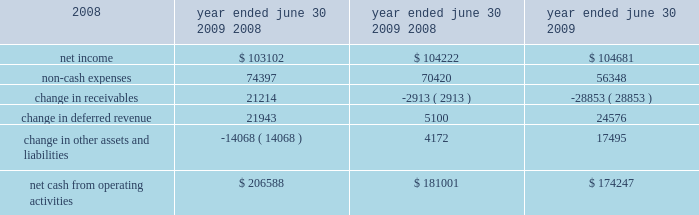26 | 2009 annual report in fiscal 2008 , revenues in the credit union systems and services business segment increased 14% ( 14 % ) from fiscal 2007 .
All revenue components within the segment experienced growth during fiscal 2008 .
License revenue generated the largest dollar growth in revenue as episys ae , our flagship core processing system aimed at larger credit unions , experienced strong sales throughout the year .
Support and service revenue , which is the largest component of total revenues for the credit union segment , experienced 34 percent growth in eft support and 10 percent growth in in-house support .
Gross profit in this business segment increased $ 9344 in fiscal 2008 compared to fiscal 2007 , due primarily to the increase in license revenue , which carries the highest margins .
Liquidity and capital resources we have historically generated positive cash flow from operations and have generally used funds generated from operations and short-term borrowings on our revolving credit facility to meet capital requirements .
We expect this trend to continue in the future .
The company 2019s cash and cash equivalents increased to $ 118251 at june 30 , 2009 from $ 65565 at june 30 , 2008 .
The table summarizes net cash from operating activities in the statement of cash flows : 2009 2008 2007 .
Year ended june 30 , cash provided by operations increased $ 25587 to $ 206588 for the fiscal year ended june 30 , 2009 as compared to $ 181001 for the fiscal year ended june 30 , 2008 .
This increase is primarily attributable to a decrease in receivables compared to the same period a year ago of $ 21214 .
This decrease is largely the result of fiscal 2010 annual software maintenance billings being provided to customers earlier than in the prior year , which allowed more cash to be collected before the end of the fiscal year than in previous years .
Further , we collected more cash overall related to revenues that will be recognized in subsequent periods in the current year than in fiscal 2008 .
Cash used in investing activities for the fiscal year ended june 2009 was $ 59227 and includes $ 3027 in contingent consideration paid on prior years 2019 acquisitions .
Cash used in investing activities for the fiscal year ended june 2008 was $ 102148 and includes payments for acquisitions of $ 48109 , plus $ 1215 in contingent consideration paid on prior years 2019 acquisitions .
Capital expenditures for fiscal 2009 were $ 31562 compared to $ 31105 for fiscal 2008 .
Cash used for software development in fiscal 2009 was $ 24684 compared to $ 23736 during the prior year .
Net cash used in financing activities for the current fiscal year was $ 94675 and includes the repurchase of 3106 shares of our common stock for $ 58405 , the payment of dividends of $ 26903 and $ 13489 net repayment on our revolving credit facilities .
Cash used in financing activities was partially offset by proceeds of $ 3773 from the exercise of stock options and the sale of common stock ( through the employee stock purchase plan ) and $ 348 excess tax benefits from stock option exercises .
During fiscal 2008 , net cash used in financing activities for the fiscal year was $ 101905 and includes the repurchase of 4200 shares of our common stock for $ 100996 , the payment of dividends of $ 24683 and $ 429 net repayment on our revolving credit facilities .
Cash used in financing activities was partially offset by proceeds of $ 20394 from the exercise of stock options and the sale of common stock and $ 3809 excess tax benefits from stock option exercises .
Beginning during fiscal 2008 , us financial markets and many of the largest us financial institutions have been shaken by negative developments in the home mortgage industry and the mortgage markets , and particularly the markets for subprime mortgage-backed securities .
Since that time , these and other such developments have resulted in a broad , global economic downturn .
While we , as is the case with most companies , have experienced the effects of this downturn , we have not experienced any significant issues with our current collection efforts , and we believe that any future impact to our liquidity will be minimized by cash generated by recurring sources of revenue and due to our access to available lines of credit. .
For the year ended june 30 , cash provided by operations increased by what percent compared to the fiscal year ended june 30 , 2008? 
Computations: (25587 / 181001)
Answer: 0.14136. 